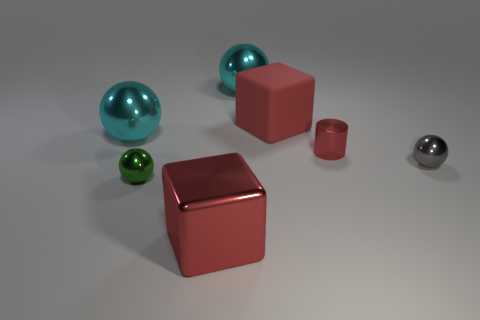Add 2 small metallic balls. How many objects exist? 9 Subtract all cyan balls. How many balls are left? 2 Subtract all small gray balls. How many balls are left? 3 Subtract all cubes. How many objects are left? 5 Subtract 2 spheres. How many spheres are left? 2 Subtract all brown cylinders. How many gray spheres are left? 1 Subtract all yellow rubber things. Subtract all big cyan balls. How many objects are left? 5 Add 4 gray metallic balls. How many gray metallic balls are left? 5 Add 6 green metal things. How many green metal things exist? 7 Subtract 1 red cylinders. How many objects are left? 6 